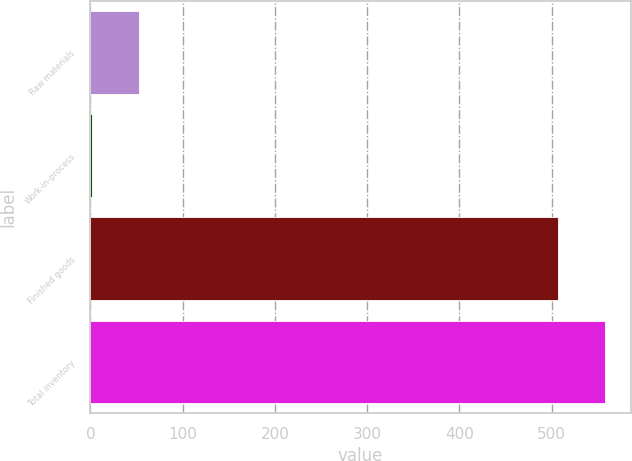Convert chart to OTSL. <chart><loc_0><loc_0><loc_500><loc_500><bar_chart><fcel>Raw materials<fcel>Work-in-process<fcel>Finished goods<fcel>Total inventory<nl><fcel>53.02<fcel>1.7<fcel>506.5<fcel>557.82<nl></chart> 